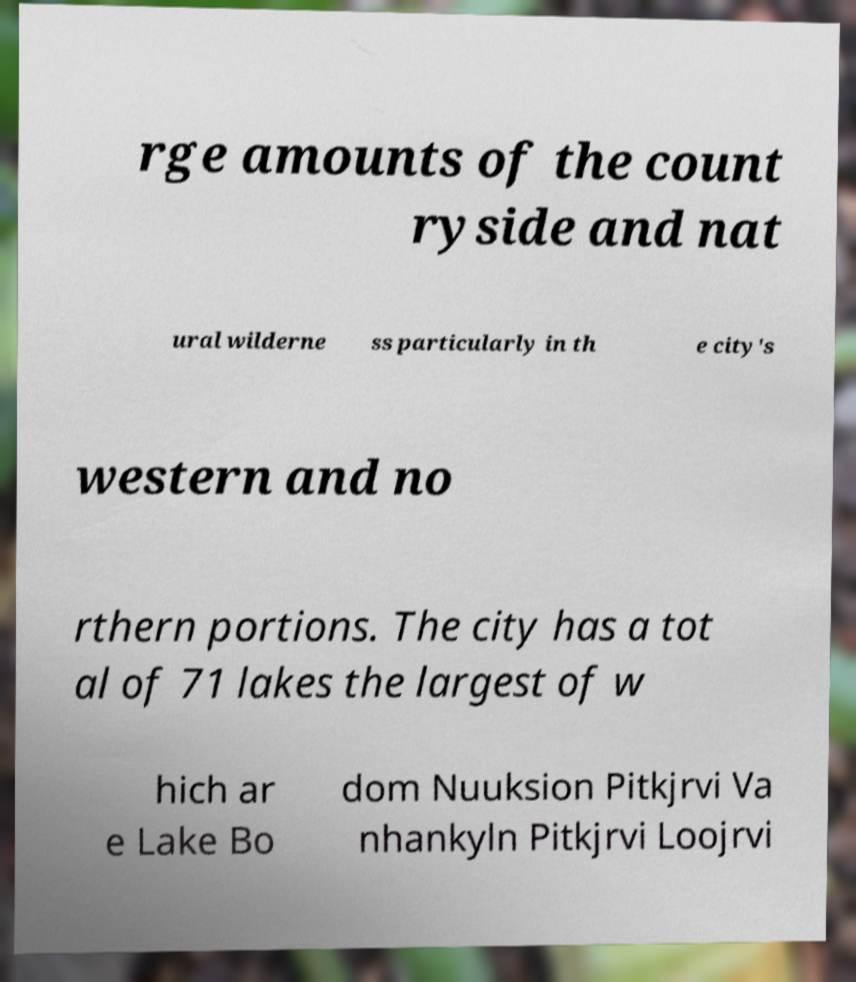For documentation purposes, I need the text within this image transcribed. Could you provide that? rge amounts of the count ryside and nat ural wilderne ss particularly in th e city's western and no rthern portions. The city has a tot al of 71 lakes the largest of w hich ar e Lake Bo dom Nuuksion Pitkjrvi Va nhankyln Pitkjrvi Loojrvi 